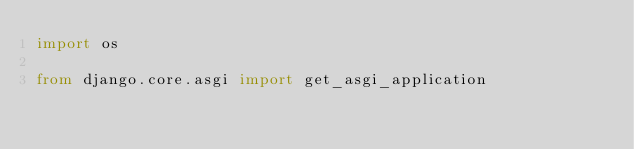Convert code to text. <code><loc_0><loc_0><loc_500><loc_500><_Python_>import os

from django.core.asgi import get_asgi_application
</code> 